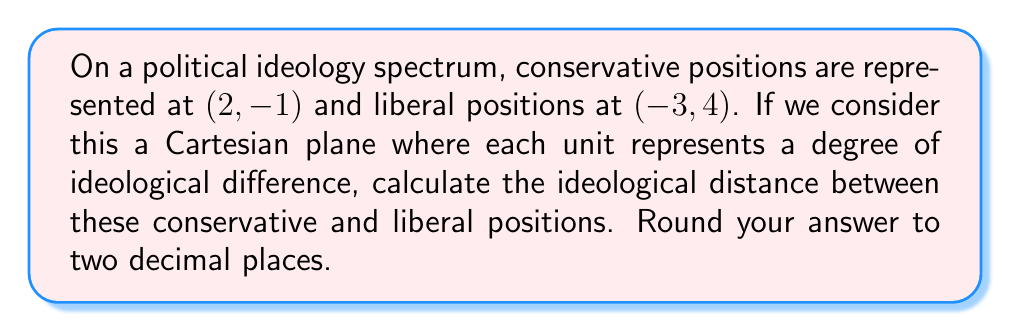Could you help me with this problem? To calculate the ideological distance between the conservative and liberal positions, we can use the distance formula derived from the Pythagorean theorem:

$$ d = \sqrt{(x_2 - x_1)^2 + (y_2 - y_1)^2} $$

Where $(x_1, y_1)$ represents the conservative position and $(x_2, y_2)$ represents the liberal position.

Let's plug in our values:
$$ d = \sqrt{(-3 - 2)^2 + (4 - (-1))^2} $$

Simplifying:
$$ d = \sqrt{(-5)^2 + (5)^2} $$

$$ d = \sqrt{25 + 25} $$

$$ d = \sqrt{50} $$

$$ d \approx 7.0711 $$

Rounding to two decimal places:
$$ d \approx 7.07 $$

This result suggests a significant ideological gap between conservative and liberal positions, which aligns with the perspective of a conservative Republican voter who might perceive substantial differences between their views and those associated with the Obama administration.
Answer: $7.07$ units 